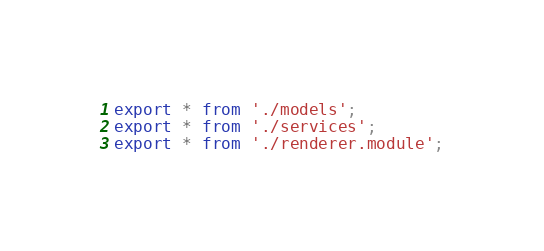<code> <loc_0><loc_0><loc_500><loc_500><_TypeScript_>export * from './models';
export * from './services';
export * from './renderer.module';
</code> 